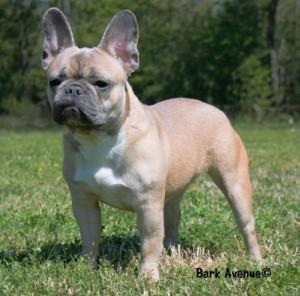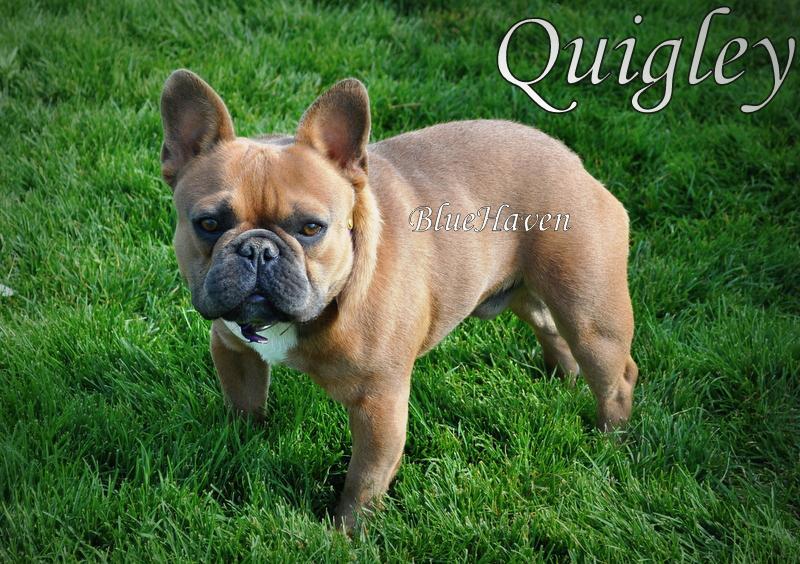The first image is the image on the left, the second image is the image on the right. Examine the images to the left and right. Is the description "There are exactly two french bulldogs that are located outdoors." accurate? Answer yes or no. Yes. The first image is the image on the left, the second image is the image on the right. Analyze the images presented: Is the assertion "The right image shows a big-eared dog with light blue eyes, and the left image shows a dog standing on all fours with its body turned forward." valid? Answer yes or no. No. 